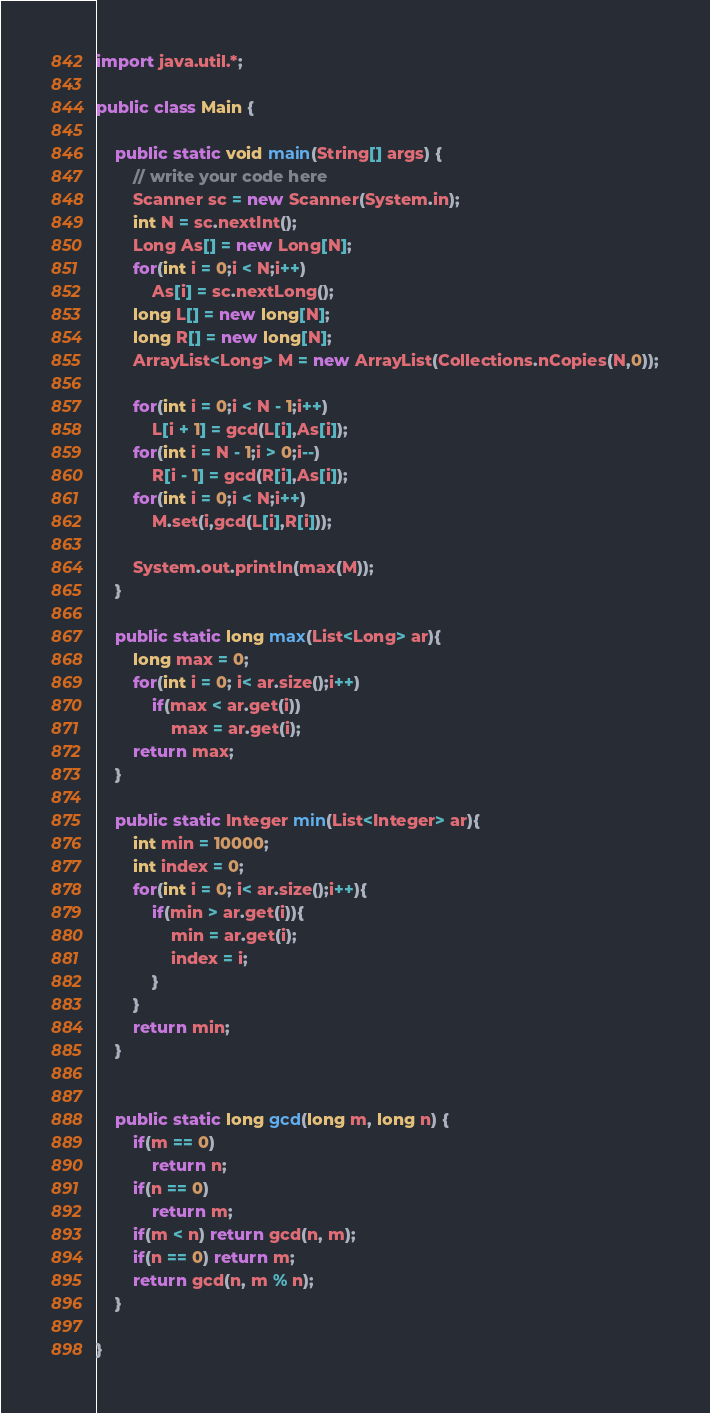<code> <loc_0><loc_0><loc_500><loc_500><_Java_>import java.util.*;

public class Main {

    public static void main(String[] args) {
        // write your code here
        Scanner sc = new Scanner(System.in);
        int N = sc.nextInt();
        Long As[] = new Long[N];
        for(int i = 0;i < N;i++)
            As[i] = sc.nextLong();
        long L[] = new long[N];
        long R[] = new long[N];
        ArrayList<Long> M = new ArrayList(Collections.nCopies(N,0));

        for(int i = 0;i < N - 1;i++)
            L[i + 1] = gcd(L[i],As[i]);
        for(int i = N - 1;i > 0;i--)
            R[i - 1] = gcd(R[i],As[i]);
        for(int i = 0;i < N;i++)
            M.set(i,gcd(L[i],R[i]));

        System.out.println(max(M));
    }

    public static long max(List<Long> ar){
        long max = 0;
        for(int i = 0; i< ar.size();i++)
            if(max < ar.get(i))
                max = ar.get(i);
        return max;
    }

    public static Integer min(List<Integer> ar){
        int min = 10000;
        int index = 0;
        for(int i = 0; i< ar.size();i++){
            if(min > ar.get(i)){
                min = ar.get(i);
                index = i;
            }
        }
        return min;
    }


    public static long gcd(long m, long n) {
        if(m == 0)
            return n;
        if(n == 0)
            return m;
        if(m < n) return gcd(n, m);
        if(n == 0) return m;
        return gcd(n, m % n);
    }

}



</code> 